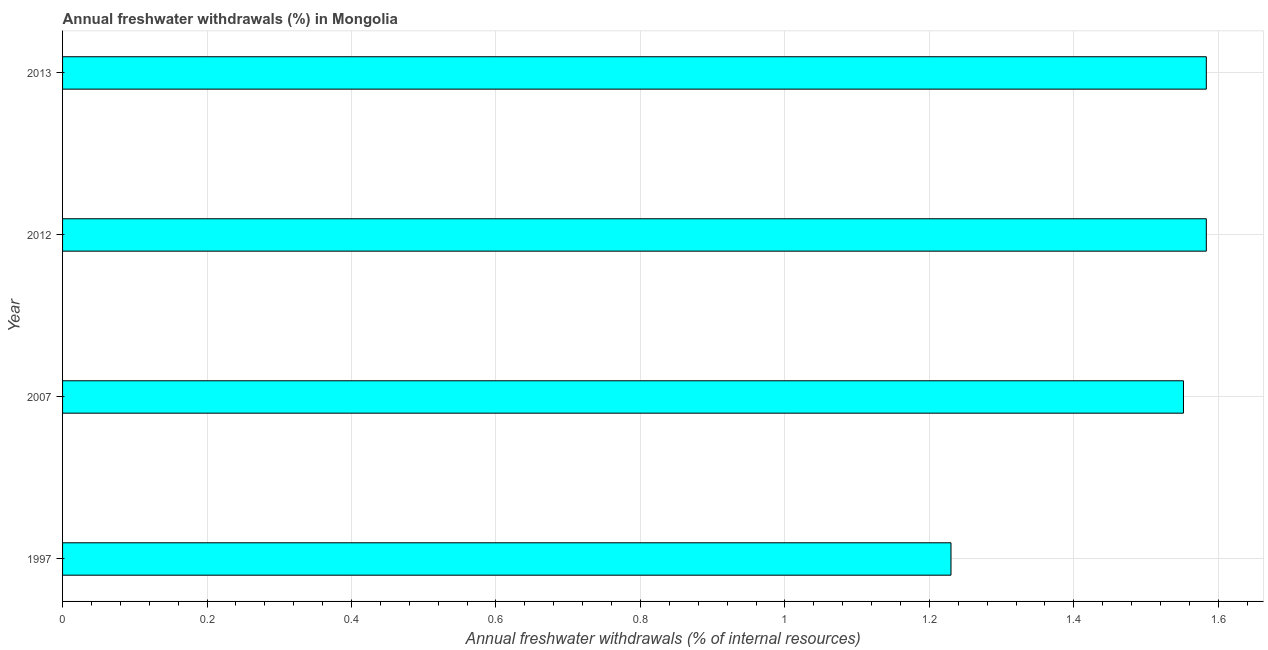Does the graph contain any zero values?
Make the answer very short. No. Does the graph contain grids?
Your answer should be very brief. Yes. What is the title of the graph?
Give a very brief answer. Annual freshwater withdrawals (%) in Mongolia. What is the label or title of the X-axis?
Ensure brevity in your answer.  Annual freshwater withdrawals (% of internal resources). What is the annual freshwater withdrawals in 2012?
Ensure brevity in your answer.  1.58. Across all years, what is the maximum annual freshwater withdrawals?
Make the answer very short. 1.58. Across all years, what is the minimum annual freshwater withdrawals?
Your answer should be very brief. 1.23. In which year was the annual freshwater withdrawals minimum?
Your response must be concise. 1997. What is the sum of the annual freshwater withdrawals?
Your answer should be compact. 5.95. What is the difference between the annual freshwater withdrawals in 2012 and 2013?
Provide a short and direct response. 0. What is the average annual freshwater withdrawals per year?
Offer a very short reply. 1.49. What is the median annual freshwater withdrawals?
Make the answer very short. 1.57. What is the ratio of the annual freshwater withdrawals in 1997 to that in 2013?
Provide a succinct answer. 0.78. Is the annual freshwater withdrawals in 2007 less than that in 2013?
Your answer should be compact. Yes. Is the difference between the annual freshwater withdrawals in 2007 and 2012 greater than the difference between any two years?
Your response must be concise. No. What is the difference between the highest and the second highest annual freshwater withdrawals?
Provide a succinct answer. 0. Is the sum of the annual freshwater withdrawals in 1997 and 2013 greater than the maximum annual freshwater withdrawals across all years?
Offer a very short reply. Yes. What is the difference between the highest and the lowest annual freshwater withdrawals?
Ensure brevity in your answer.  0.35. In how many years, is the annual freshwater withdrawals greater than the average annual freshwater withdrawals taken over all years?
Keep it short and to the point. 3. Are all the bars in the graph horizontal?
Give a very brief answer. Yes. What is the Annual freshwater withdrawals (% of internal resources) in 1997?
Provide a short and direct response. 1.23. What is the Annual freshwater withdrawals (% of internal resources) of 2007?
Your answer should be very brief. 1.55. What is the Annual freshwater withdrawals (% of internal resources) in 2012?
Give a very brief answer. 1.58. What is the Annual freshwater withdrawals (% of internal resources) of 2013?
Offer a very short reply. 1.58. What is the difference between the Annual freshwater withdrawals (% of internal resources) in 1997 and 2007?
Your answer should be compact. -0.32. What is the difference between the Annual freshwater withdrawals (% of internal resources) in 1997 and 2012?
Give a very brief answer. -0.35. What is the difference between the Annual freshwater withdrawals (% of internal resources) in 1997 and 2013?
Your response must be concise. -0.35. What is the difference between the Annual freshwater withdrawals (% of internal resources) in 2007 and 2012?
Provide a succinct answer. -0.03. What is the difference between the Annual freshwater withdrawals (% of internal resources) in 2007 and 2013?
Your answer should be very brief. -0.03. What is the difference between the Annual freshwater withdrawals (% of internal resources) in 2012 and 2013?
Provide a succinct answer. 0. What is the ratio of the Annual freshwater withdrawals (% of internal resources) in 1997 to that in 2007?
Your answer should be compact. 0.79. What is the ratio of the Annual freshwater withdrawals (% of internal resources) in 1997 to that in 2012?
Your answer should be compact. 0.78. What is the ratio of the Annual freshwater withdrawals (% of internal resources) in 1997 to that in 2013?
Your response must be concise. 0.78. What is the ratio of the Annual freshwater withdrawals (% of internal resources) in 2007 to that in 2012?
Keep it short and to the point. 0.98. 